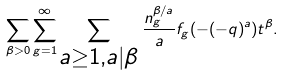<formula> <loc_0><loc_0><loc_500><loc_500>\sum _ { \beta > 0 } \sum _ { g = 1 } ^ { \infty } \sum _ { \begin{subarray} { c } a \geq 1 , a | \beta \end{subarray} } \frac { n _ { g } ^ { \beta / a } } { a } f _ { g } ( - ( - q ) ^ { a } ) t ^ { \beta } .</formula> 